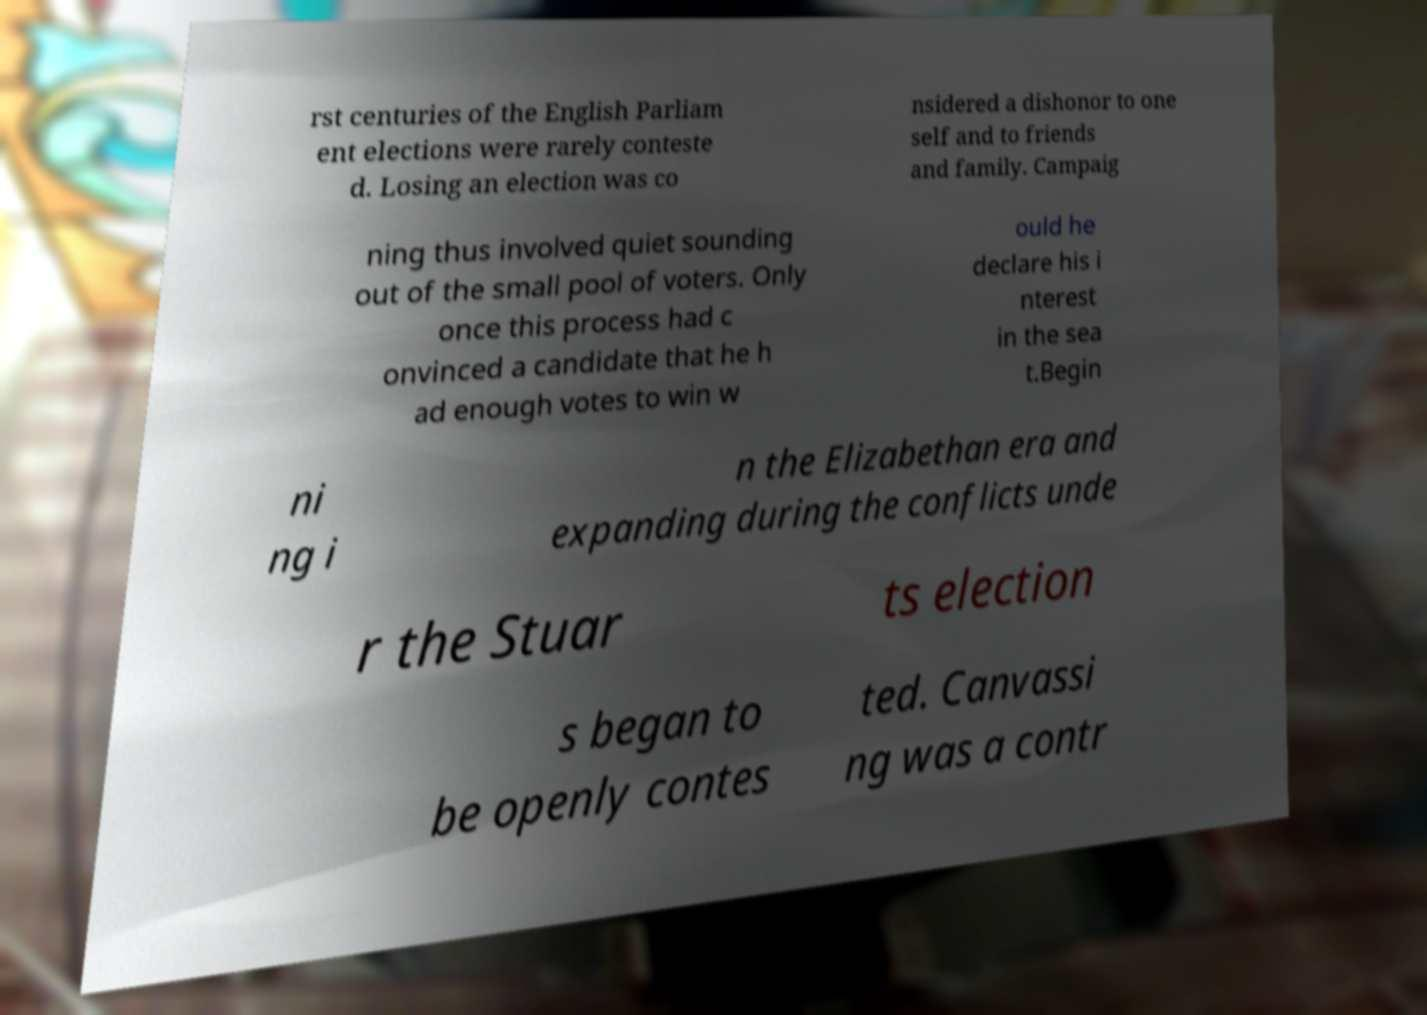Can you read and provide the text displayed in the image?This photo seems to have some interesting text. Can you extract and type it out for me? rst centuries of the English Parliam ent elections were rarely conteste d. Losing an election was co nsidered a dishonor to one self and to friends and family. Campaig ning thus involved quiet sounding out of the small pool of voters. Only once this process had c onvinced a candidate that he h ad enough votes to win w ould he declare his i nterest in the sea t.Begin ni ng i n the Elizabethan era and expanding during the conflicts unde r the Stuar ts election s began to be openly contes ted. Canvassi ng was a contr 